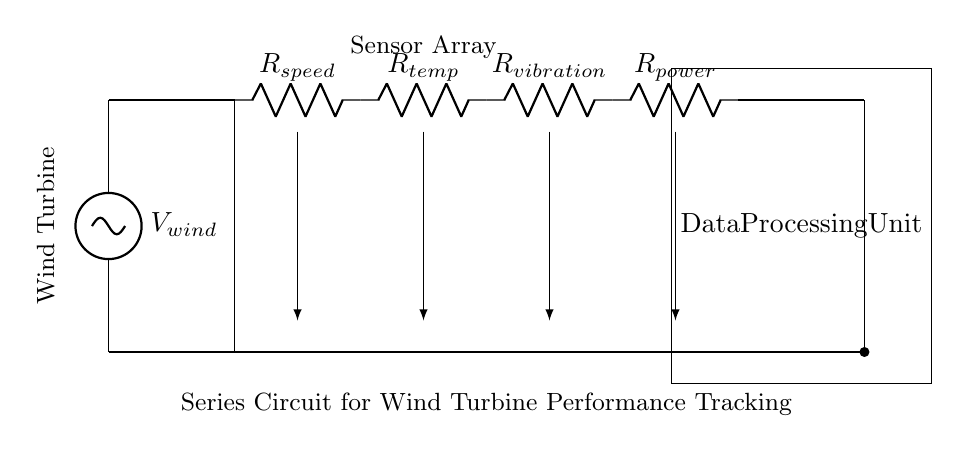What is the main source of voltage in this circuit? The voltage source is identified as \( V_{wind} \) at the top of the circuit diagram. It provides the necessary voltage for the entire circuit.
Answer: V wind How many resistors are present in the circuit? The circuit diagram shows four resistors labeled \( R_{speed} \), \( R_{temp} \), \( R_{vibration} \), and \( R_{power} \). Each of these is connected in series, indicating they are counted individually.
Answer: 4 What is the role of the Data Processing Unit in this circuit? The Data Processing Unit is responsible for processing the data output from the sensors connected in series. It collects measurements from resistors outputting data for tracking performance.
Answer: Data Processing Explain how the voltage drops across the resistors affect the performance of the wind turbine. The voltage drop across each resistor represents the energy consumed by each sensor. The total current flowing through the series circuit is the same, and the voltage drop on each resistor indicates how each sensor affects the performance. More resistance leads to less current, impacting data accuracy.
Answer: Voltage drop impacts performance What type of circuit is represented in this diagram? The circuit consists of components connected end-to-end, where current flows in a single path through each component, identifying it as a series circuit. The flow of current is uniform across all components.
Answer: Series circuit How does the arrangement of the sensors influence the readout of the system? Since this is a series circuit, the same current flows through all sensors, meaning the readouts of the sensors are affected by the total resistance and voltage applied. This arrangement allows collective performance tracking.
Answer: Collective tracking 